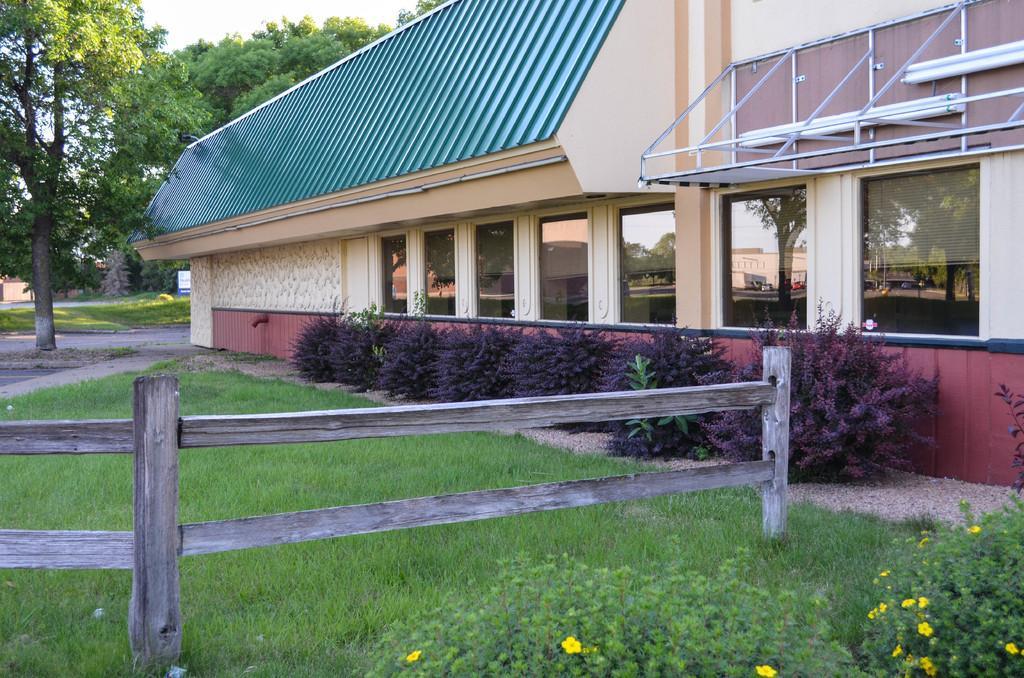Can you describe this image briefly? In this image I can see yellow flower plants. There is a wooden fence, grass, plants and a building on the left which has glass windows. There are trees at the back. 